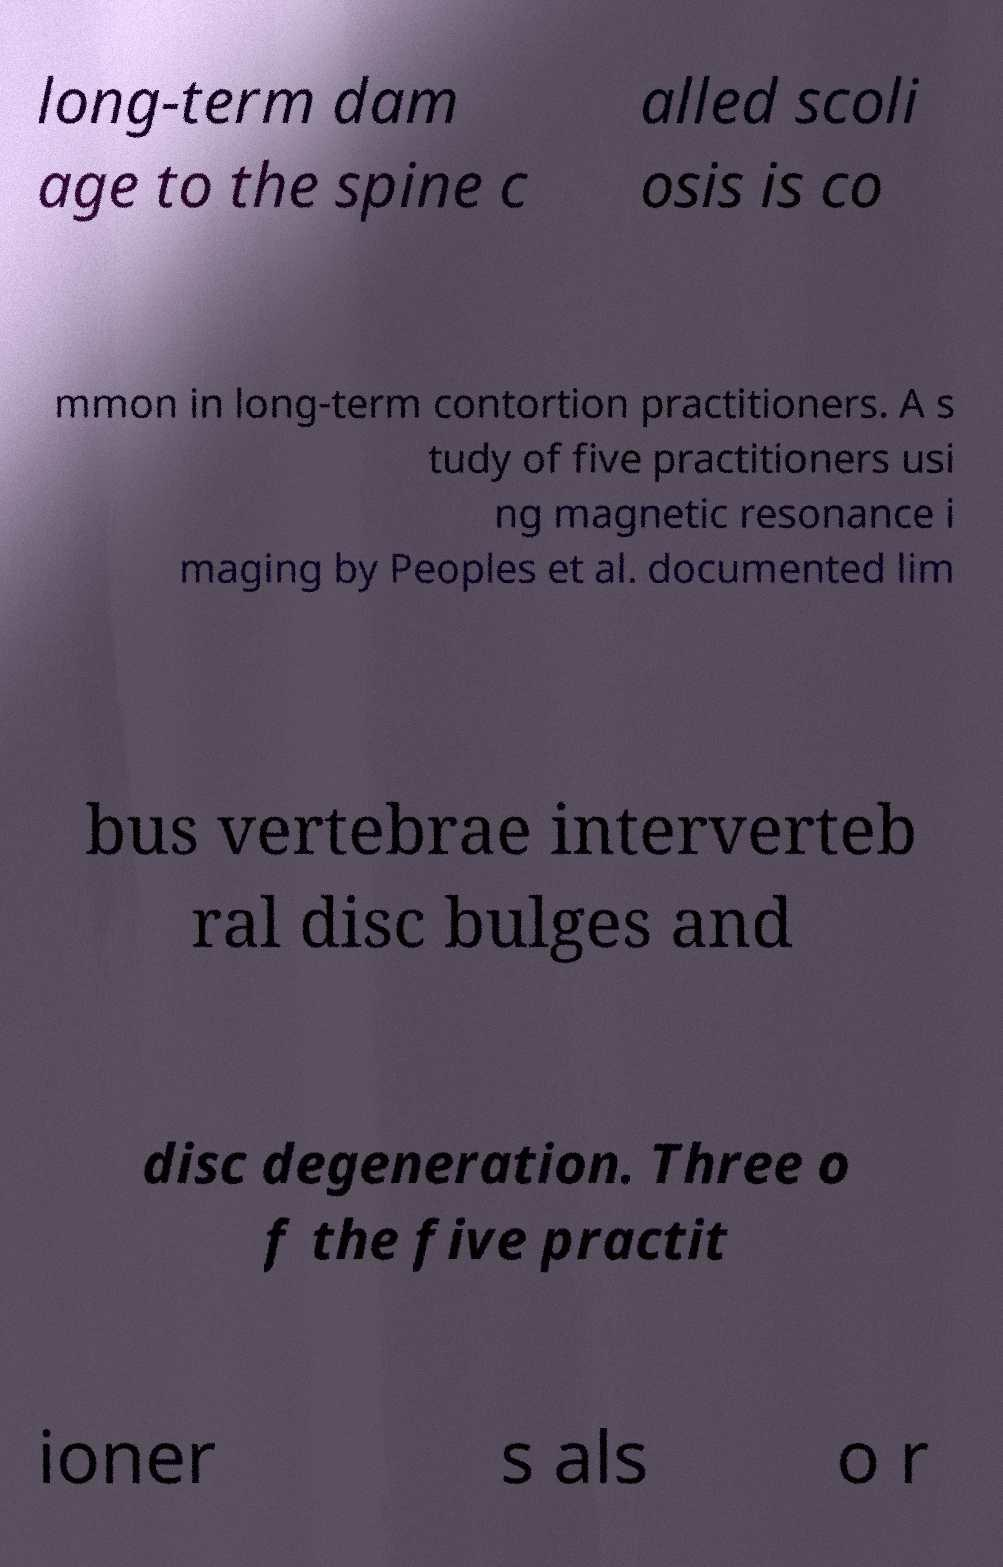Can you accurately transcribe the text from the provided image for me? long-term dam age to the spine c alled scoli osis is co mmon in long-term contortion practitioners. A s tudy of five practitioners usi ng magnetic resonance i maging by Peoples et al. documented lim bus vertebrae interverteb ral disc bulges and disc degeneration. Three o f the five practit ioner s als o r 